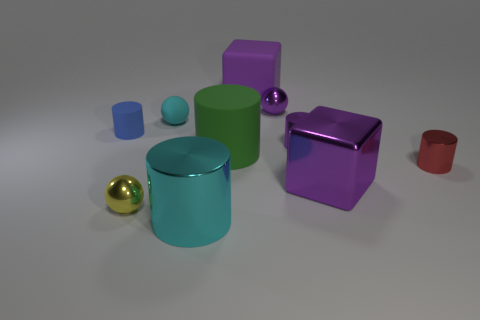What size is the metallic cylinder that is the same color as the rubber sphere?
Keep it short and to the point. Large. What number of other objects are the same size as the green thing?
Your answer should be very brief. 3. There is a cylinder that is left of the big rubber cylinder and right of the blue object; what size is it?
Give a very brief answer. Large. How many other purple objects are the same shape as the large purple matte object?
Make the answer very short. 1. What is the material of the blue cylinder?
Make the answer very short. Rubber. Do the cyan matte object and the big cyan metallic thing have the same shape?
Your response must be concise. No. Are there any other blue cylinders that have the same material as the blue cylinder?
Keep it short and to the point. No. What color is the big object that is behind the small red thing and in front of the purple rubber cube?
Provide a succinct answer. Green. There is a block behind the green object; what material is it?
Offer a terse response. Rubber. Are there any other small yellow rubber objects of the same shape as the yellow object?
Your response must be concise. No. 